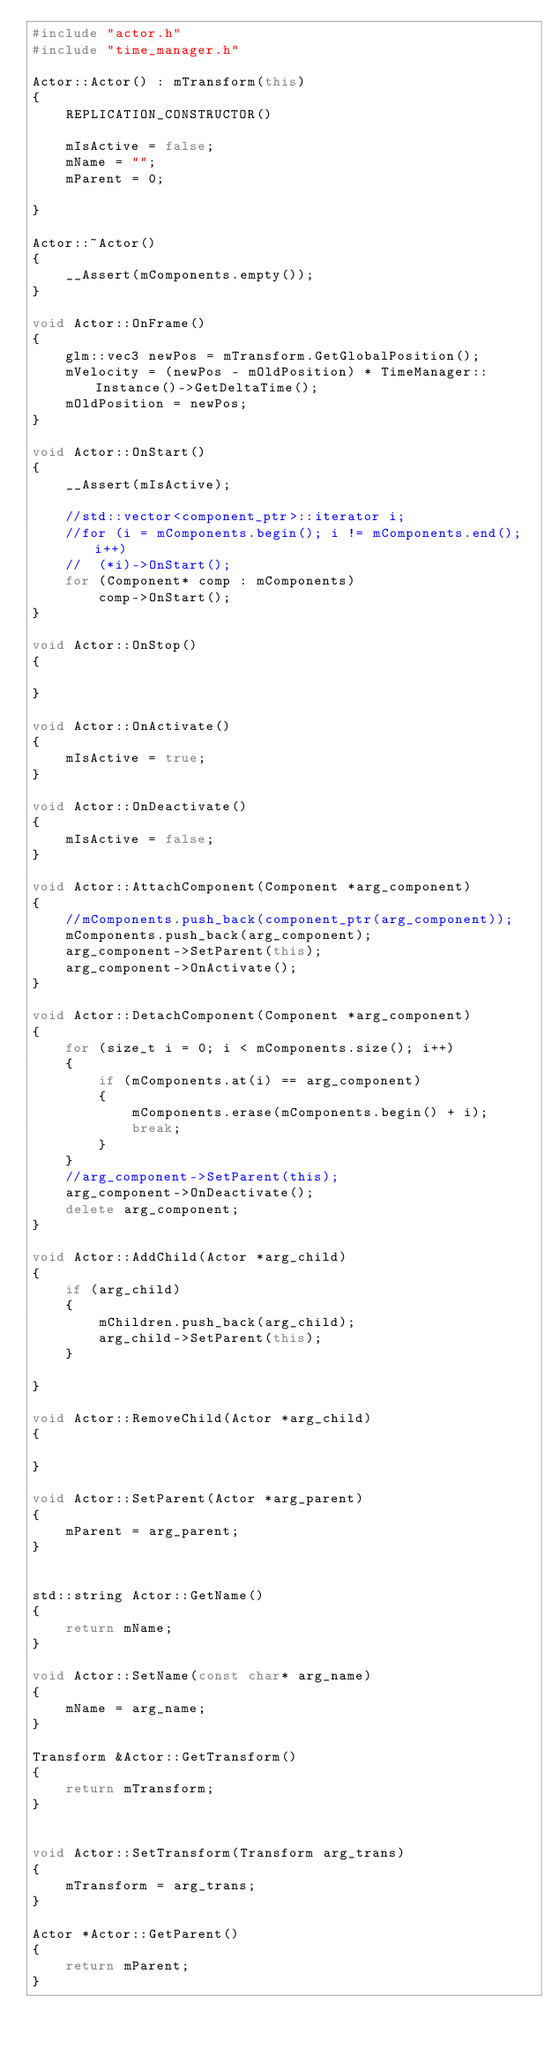<code> <loc_0><loc_0><loc_500><loc_500><_C++_>#include "actor.h"
#include "time_manager.h"

Actor::Actor() : mTransform(this)
{
	REPLICATION_CONSTRUCTOR()

	mIsActive = false;
	mName = "";
	mParent = 0;
	
}

Actor::~Actor()
{
	__Assert(mComponents.empty());
}

void Actor::OnFrame()
{
	glm::vec3 newPos = mTransform.GetGlobalPosition();
	mVelocity = (newPos - mOldPosition) * TimeManager::Instance()->GetDeltaTime();
	mOldPosition = newPos;
}

void Actor::OnStart()
{
	__Assert(mIsActive);

	//std::vector<component_ptr>::iterator i;
	//for (i = mComponents.begin(); i != mComponents.end(); i++)
	//	(*i)->OnStart();
	for (Component* comp : mComponents)
		comp->OnStart();
}

void Actor::OnStop()
{

}

void Actor::OnActivate()
{
	mIsActive = true;
}

void Actor::OnDeactivate()
{
	mIsActive = false;
}

void Actor::AttachComponent(Component *arg_component)
{
	//mComponents.push_back(component_ptr(arg_component));
	mComponents.push_back(arg_component);
	arg_component->SetParent(this);
	arg_component->OnActivate();
}

void Actor::DetachComponent(Component *arg_component)
{
	for (size_t i = 0; i < mComponents.size(); i++)
	{
		if (mComponents.at(i) == arg_component)
		{
			mComponents.erase(mComponents.begin() + i);
			break;
		}
	}
	//arg_component->SetParent(this);
	arg_component->OnDeactivate();
	delete arg_component;
}

void Actor::AddChild(Actor *arg_child)
{
	if (arg_child)
	{
		mChildren.push_back(arg_child);
		arg_child->SetParent(this);
	}
	
}

void Actor::RemoveChild(Actor *arg_child)
{
	
}

void Actor::SetParent(Actor *arg_parent)
{
	mParent = arg_parent;
}


std::string Actor::GetName()
{
	return mName;
}

void Actor::SetName(const char* arg_name)
{
	mName = arg_name;
}

Transform &Actor::GetTransform()
{
	return mTransform;
}


void Actor::SetTransform(Transform arg_trans)
{
	mTransform = arg_trans;
}

Actor *Actor::GetParent()
{
	return mParent;
}
</code> 